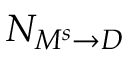<formula> <loc_0><loc_0><loc_500><loc_500>N _ { M ^ { s } \rightarrow D }</formula> 